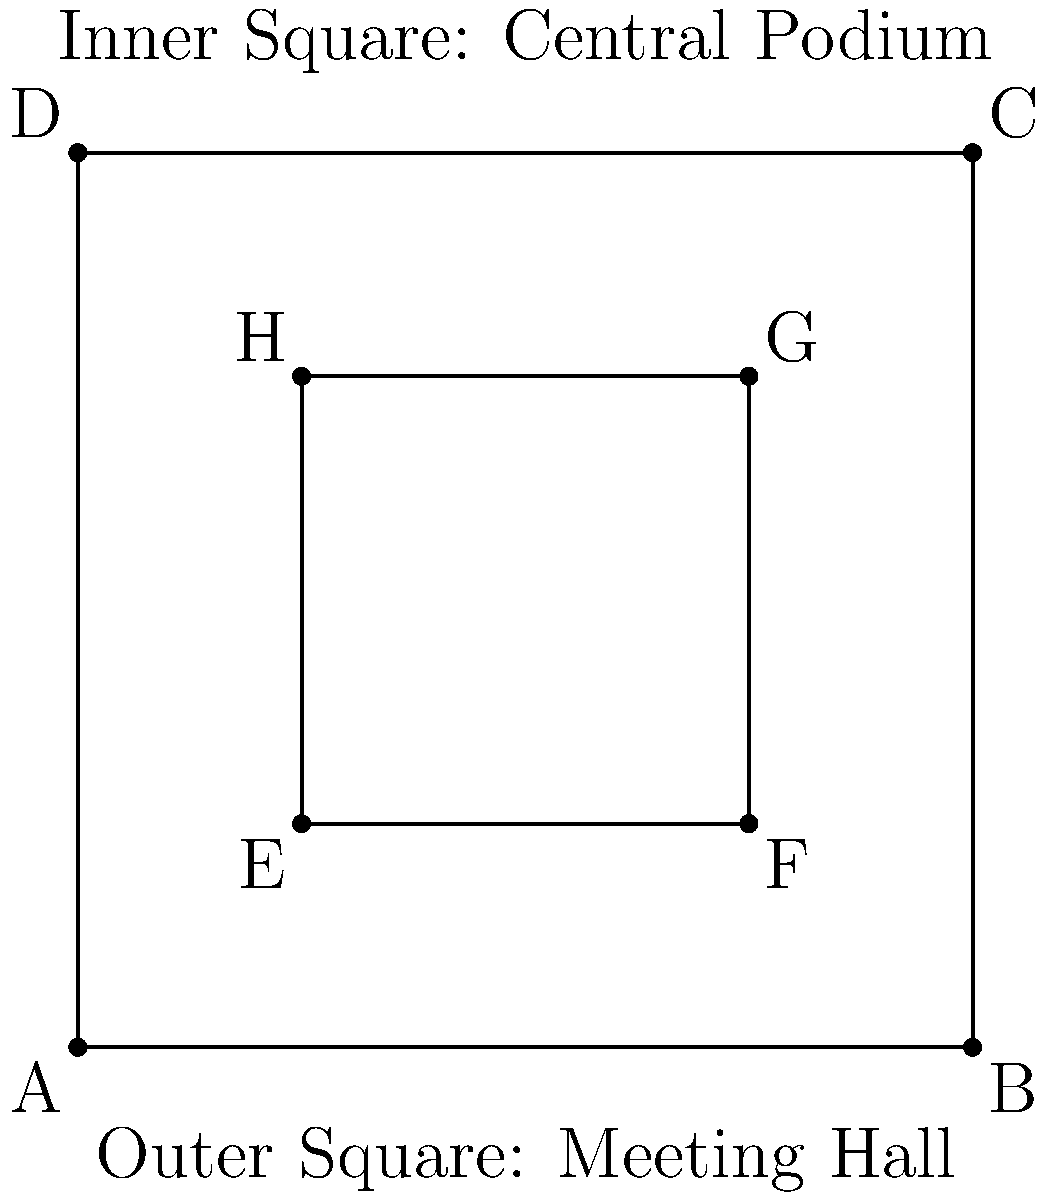Consider the symmetrical design of an 18th-century scientific academy's meeting hall, represented by the outer square ABCD, with a central podium represented by the inner square EFGH. How many symmetry operations (including the identity) does this design possess, and what group does it form? Let's analyze the symmetries step-by-step:

1. Rotational symmetries:
   - 360° (identity)
   - 90° clockwise
   - 180°
   - 270° clockwise (90° counterclockwise)
   Total: 4 rotational symmetries

2. Reflection symmetries:
   - Across vertical axis
   - Across horizontal axis
   - Across diagonal from top-left to bottom-right
   - Across diagonal from top-right to bottom-left
   Total: 4 reflection symmetries

3. Total number of symmetry operations:
   4 (rotations) + 4 (reflections) = 8 symmetry operations

4. Group identification:
   - The group has 8 elements
   - It includes rotations and reflections
   - The composition of these operations is closed
   - The identity element exists
   - Each element has an inverse
   - The operations are associative

These properties correspond to the dihedral group $D_4$, which is the symmetry group of a square.
Answer: 8 symmetry operations; Dihedral group $D_4$ 